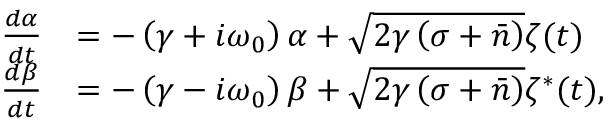<formula> <loc_0><loc_0><loc_500><loc_500>\begin{array} { r l } { \frac { d \alpha } { d t } } & { = - \left ( \gamma + i \omega _ { 0 } \right ) \alpha + \sqrt { 2 \gamma \left ( \sigma + \bar { n } \right ) } \zeta ( t ) } \\ { \frac { d \beta } { d t } } & { = - \left ( \gamma - i \omega _ { 0 } \right ) \beta + \sqrt { 2 \gamma \left ( \sigma + \bar { n } \right ) } \zeta ^ { * } ( t ) , } \end{array}</formula> 